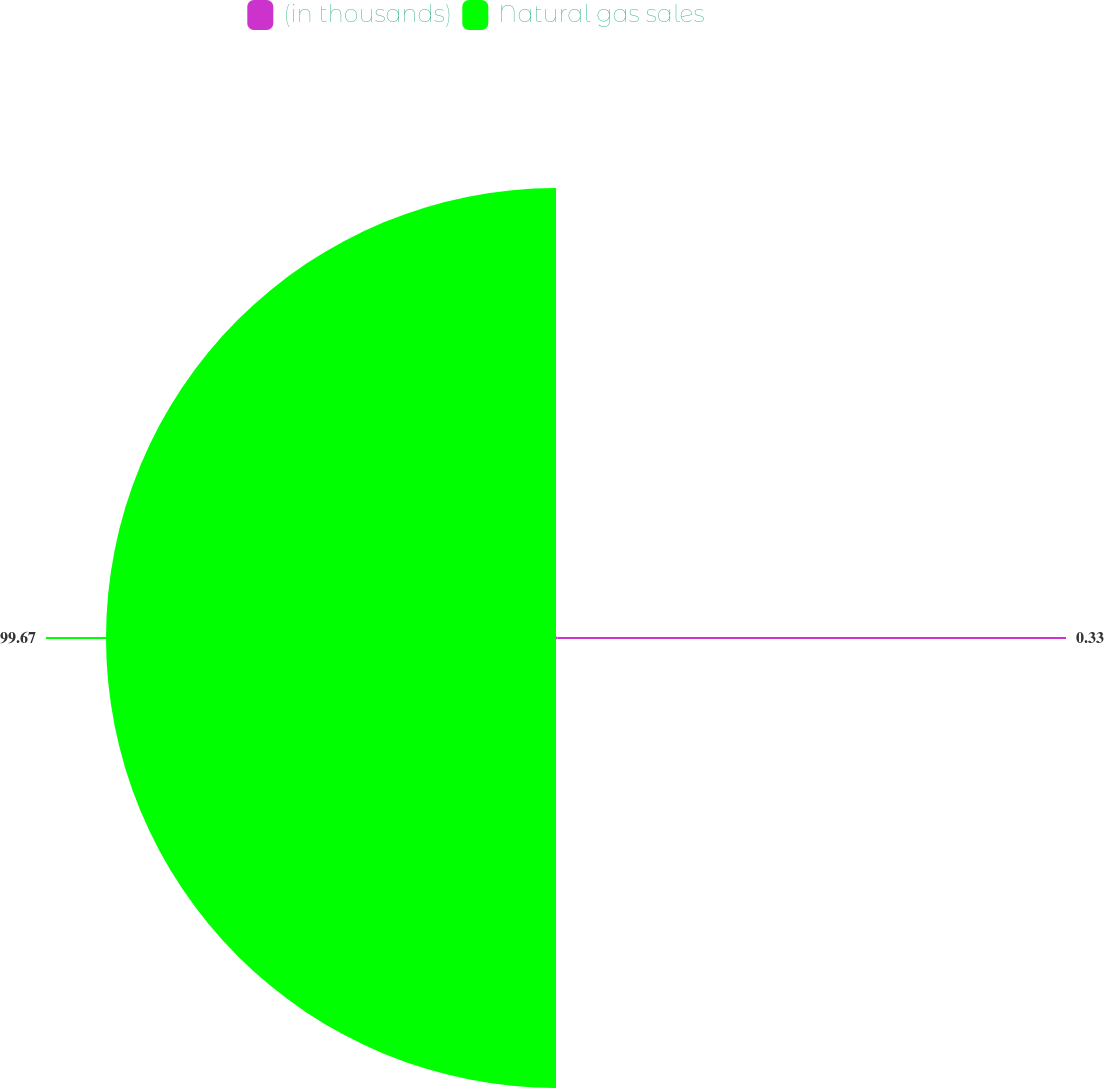<chart> <loc_0><loc_0><loc_500><loc_500><pie_chart><fcel>(in thousands)<fcel>Natural gas sales<nl><fcel>0.33%<fcel>99.67%<nl></chart> 